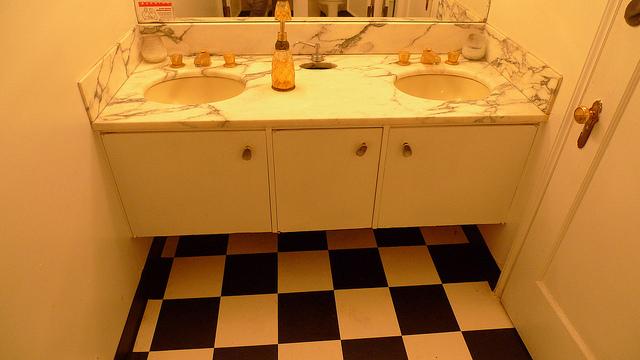What pattern is the floor?
Quick response, please. Checkered. Is this a public bathroom?
Be succinct. No. What is the counter made of?
Give a very brief answer. Marble. 